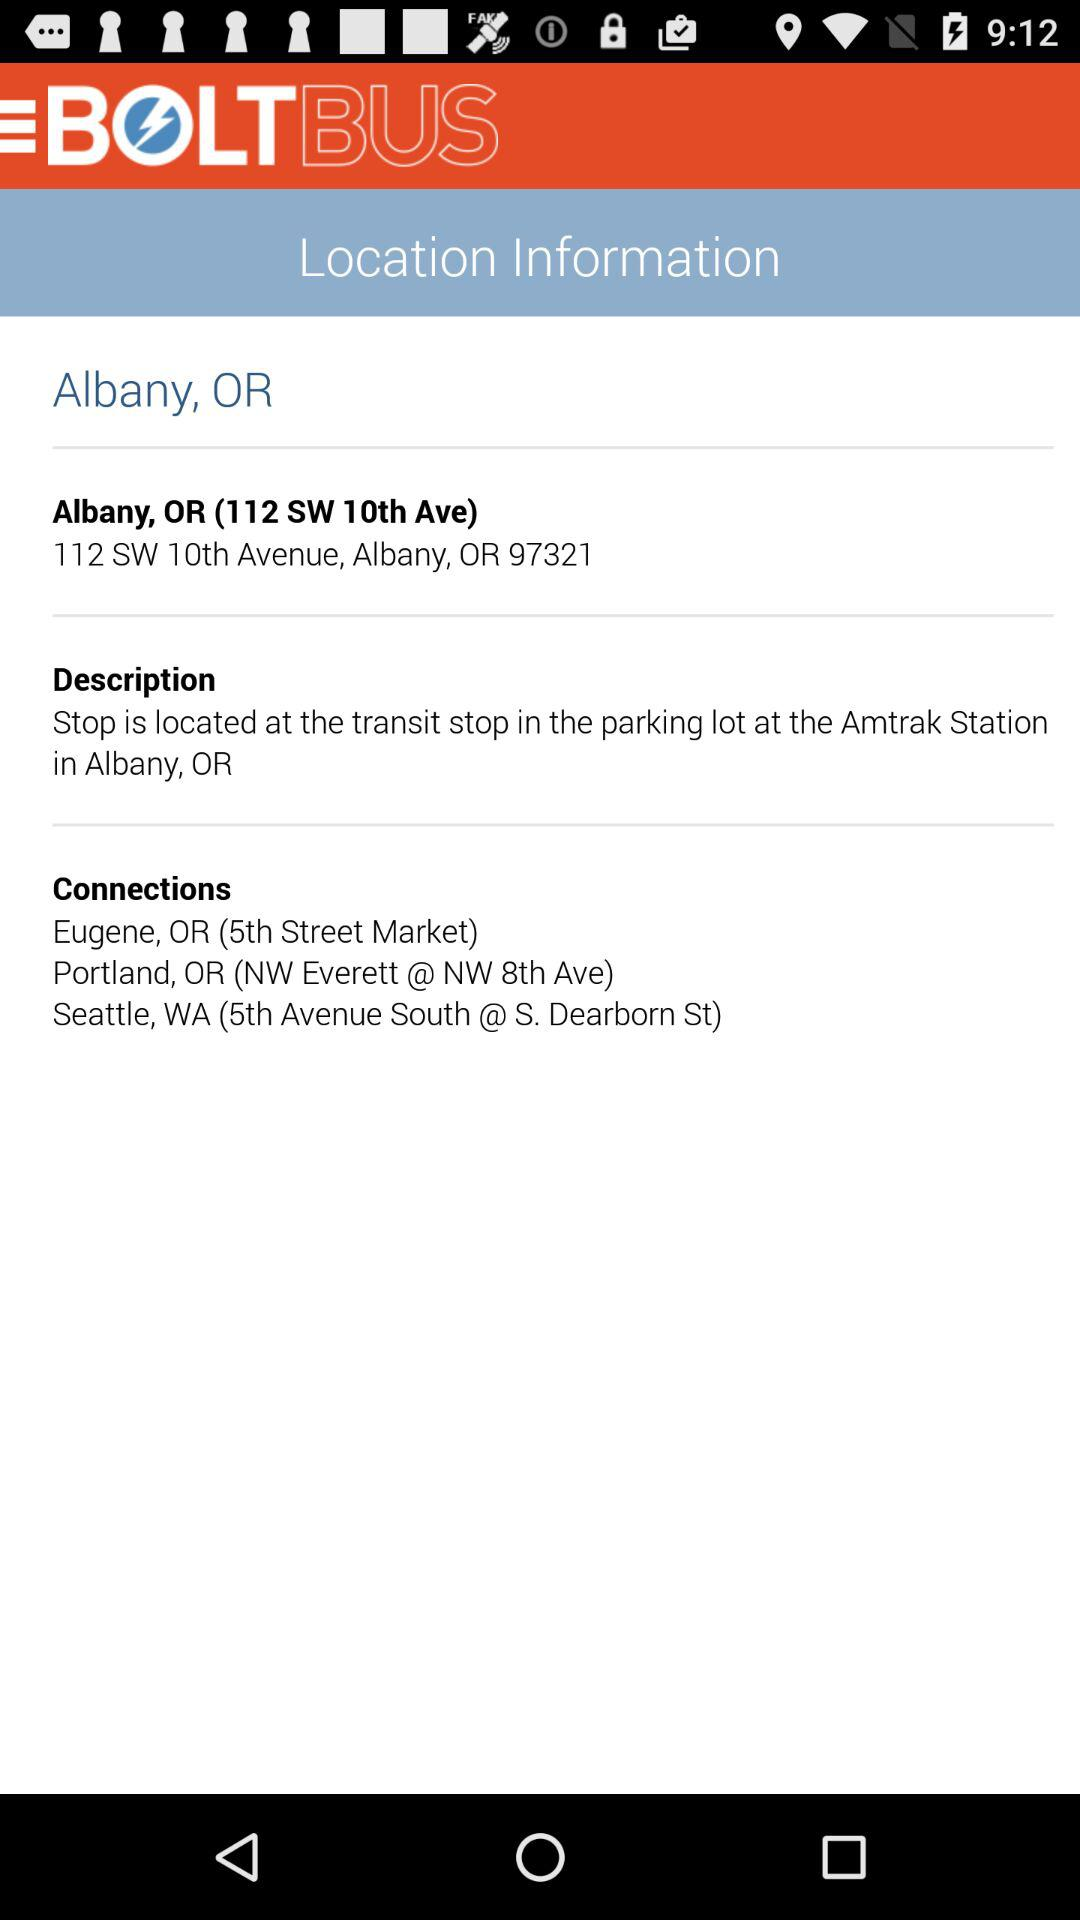How much does the bus ticket cost?
When the provided information is insufficient, respond with <no answer>. <no answer> 